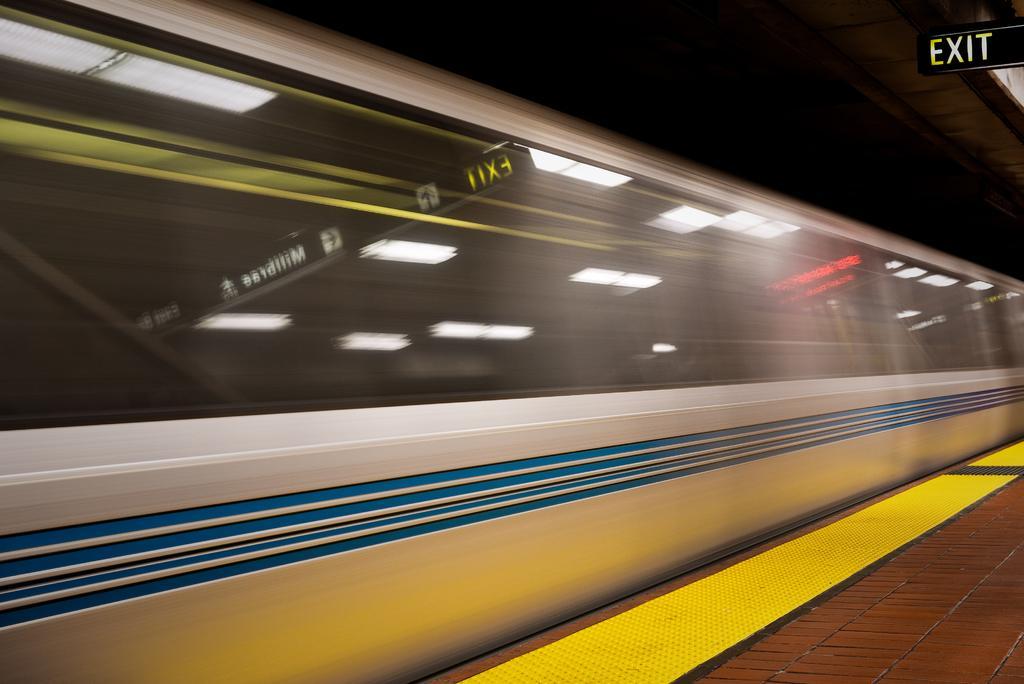Can you describe this image briefly? In this image there is a train in middle of this image and there is a floor in the bottom of this image, and there is a exit board on the top right corner of this image. 